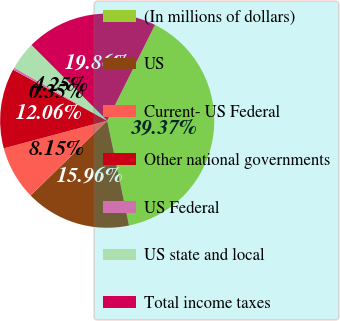<chart> <loc_0><loc_0><loc_500><loc_500><pie_chart><fcel>(In millions of dollars)<fcel>US<fcel>Current- US Federal<fcel>Other national governments<fcel>US Federal<fcel>US state and local<fcel>Total income taxes<nl><fcel>39.37%<fcel>15.96%<fcel>8.15%<fcel>12.06%<fcel>0.35%<fcel>4.25%<fcel>19.86%<nl></chart> 